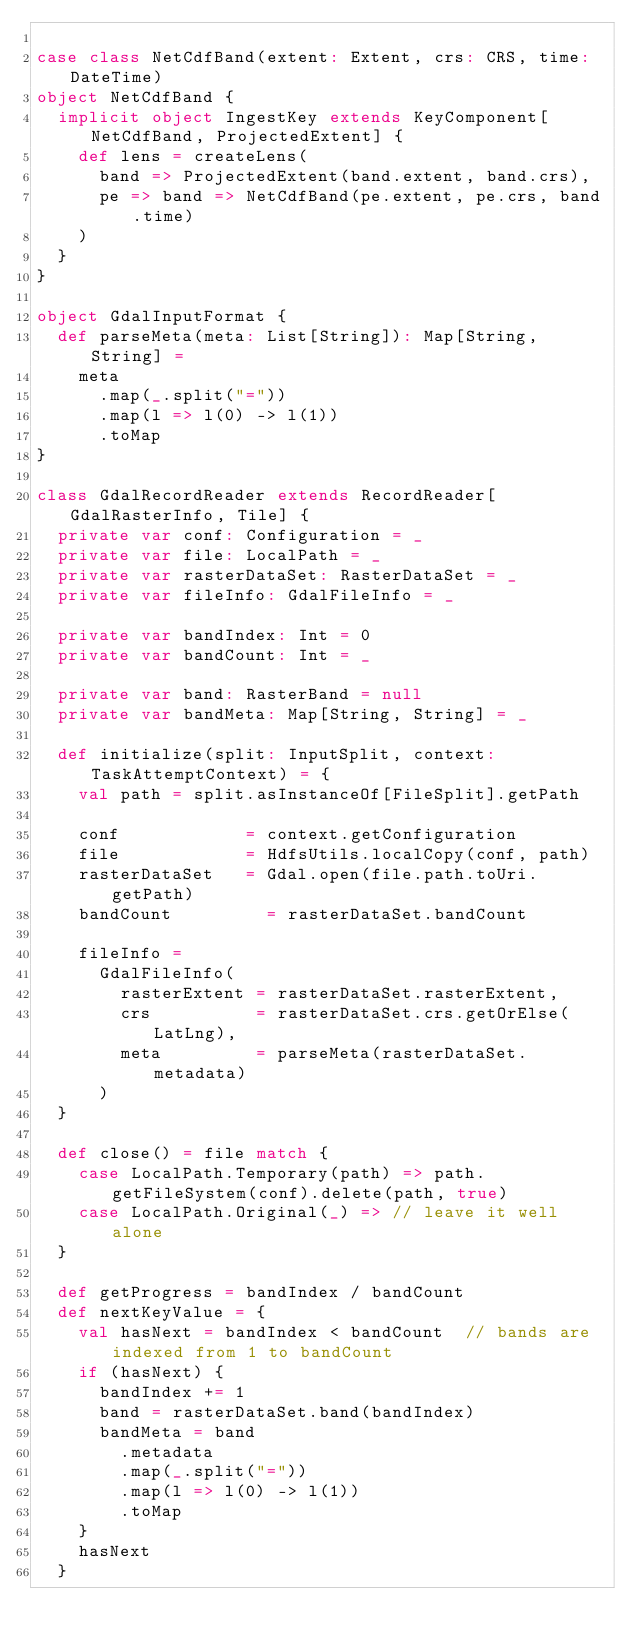<code> <loc_0><loc_0><loc_500><loc_500><_Scala_>
case class NetCdfBand(extent: Extent, crs: CRS, time: DateTime)
object NetCdfBand {
  implicit object IngestKey extends KeyComponent[NetCdfBand, ProjectedExtent] {
    def lens = createLens(
      band => ProjectedExtent(band.extent, band.crs),
      pe => band => NetCdfBand(pe.extent, pe.crs, band.time)
    )
  }
}

object GdalInputFormat {
  def parseMeta(meta: List[String]): Map[String, String] =
    meta
      .map(_.split("="))
      .map(l => l(0) -> l(1))
      .toMap
}

class GdalRecordReader extends RecordReader[GdalRasterInfo, Tile] {
  private var conf: Configuration = _
  private var file: LocalPath = _
  private var rasterDataSet: RasterDataSet = _
  private var fileInfo: GdalFileInfo = _

  private var bandIndex: Int = 0
  private var bandCount: Int = _

  private var band: RasterBand = null
  private var bandMeta: Map[String, String] = _

  def initialize(split: InputSplit, context: TaskAttemptContext) = {
    val path = split.asInstanceOf[FileSplit].getPath

    conf            = context.getConfiguration
    file            = HdfsUtils.localCopy(conf, path)
    rasterDataSet   = Gdal.open(file.path.toUri.getPath)
    bandCount         = rasterDataSet.bandCount

    fileInfo =
      GdalFileInfo(
        rasterExtent = rasterDataSet.rasterExtent,
        crs          = rasterDataSet.crs.getOrElse(LatLng),
        meta         = parseMeta(rasterDataSet.metadata)
      )
  }

  def close() = file match {
    case LocalPath.Temporary(path) => path.getFileSystem(conf).delete(path, true)
    case LocalPath.Original(_) => // leave it well alone
  }

  def getProgress = bandIndex / bandCount
  def nextKeyValue = {
    val hasNext = bandIndex < bandCount  // bands are indexed from 1 to bandCount
    if (hasNext) {
      bandIndex += 1
      band = rasterDataSet.band(bandIndex)
      bandMeta = band
        .metadata
        .map(_.split("="))
        .map(l => l(0) -> l(1))
        .toMap
    }
    hasNext
  }</code> 